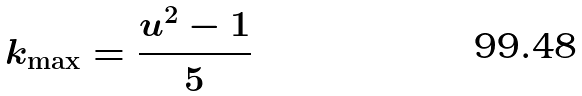<formula> <loc_0><loc_0><loc_500><loc_500>k _ { \max } = \frac { u ^ { 2 } - 1 } { 5 }</formula> 